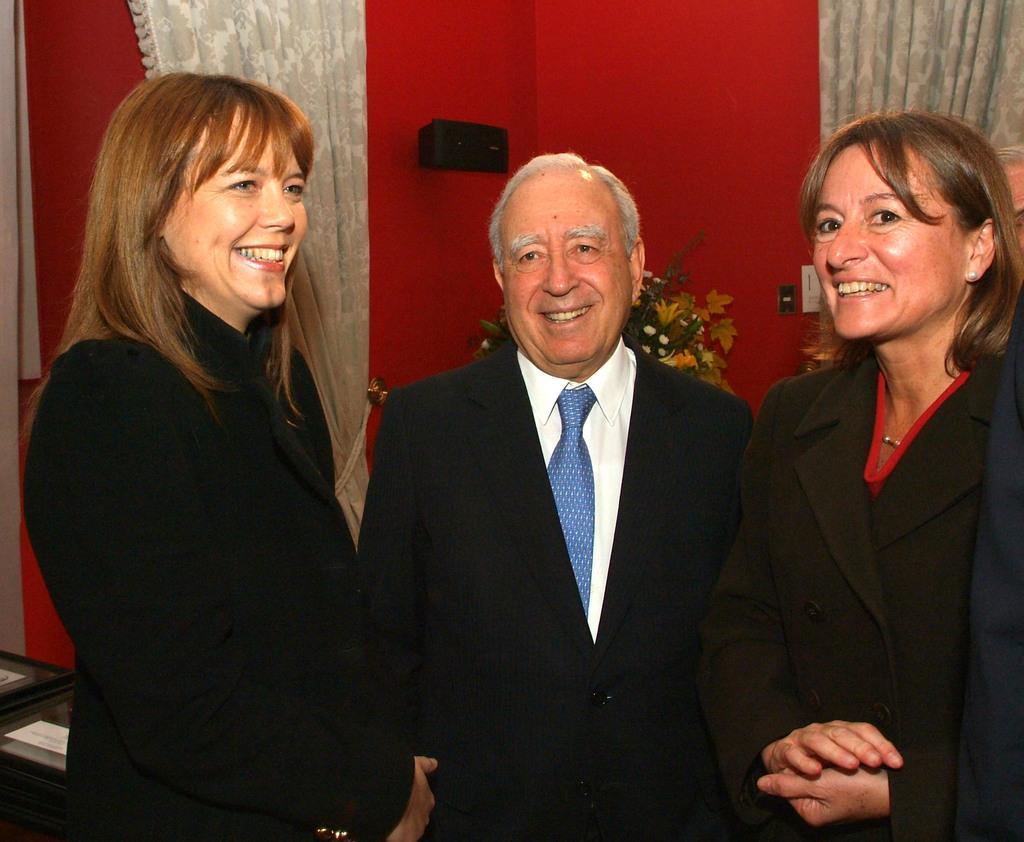Describe this image in one or two sentences. This picture might be taken inside the room. In this image, we can see three people standing. In the background, we can see plant with some flowers, wall, curtains and a red color wall. 